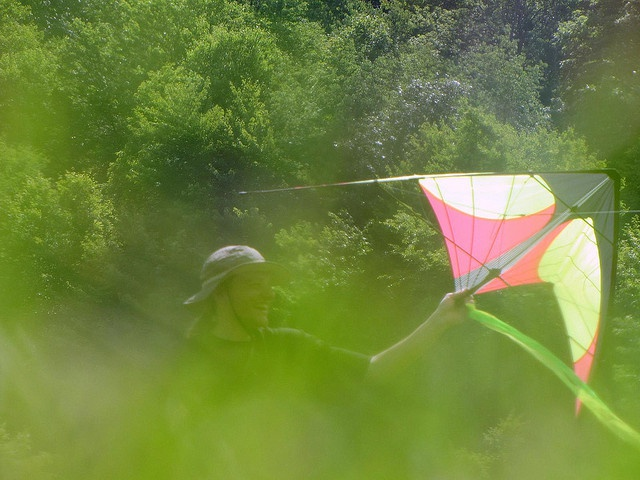Describe the objects in this image and their specific colors. I can see people in olive tones and kite in olive, ivory, khaki, and lightpink tones in this image. 